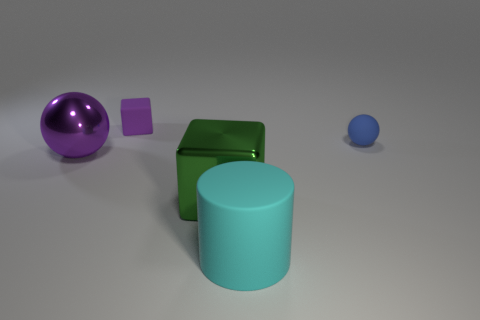The green thing that is the same shape as the small purple rubber thing is what size?
Your answer should be very brief. Large. Are there any cubes behind the big sphere?
Ensure brevity in your answer.  Yes. What is the material of the tiny purple thing?
Provide a short and direct response. Rubber. There is a object behind the tiny rubber ball; is it the same color as the big shiny ball?
Your response must be concise. Yes. Is there anything else that is the same shape as the small purple thing?
Provide a succinct answer. Yes. There is a rubber thing that is the same shape as the big purple shiny thing; what is its color?
Your response must be concise. Blue. What is the block in front of the large purple metallic ball made of?
Ensure brevity in your answer.  Metal. The small sphere is what color?
Provide a short and direct response. Blue. There is a thing behind the blue rubber ball; does it have the same size as the tiny blue sphere?
Make the answer very short. Yes. There is a ball that is left of the purple thing that is behind the sphere in front of the tiny blue object; what is its material?
Provide a short and direct response. Metal. 